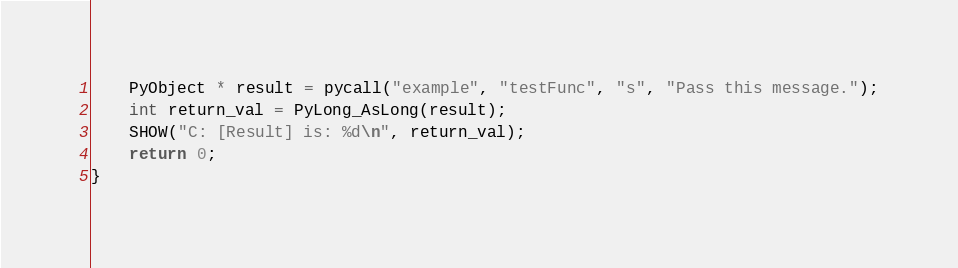Convert code to text. <code><loc_0><loc_0><loc_500><loc_500><_C_>    PyObject * result = pycall("example", "testFunc", "s", "Pass this message.");
    int return_val = PyLong_AsLong(result);
    SHOW("C: [Result] is: %d\n", return_val);
    return 0;
}
</code> 